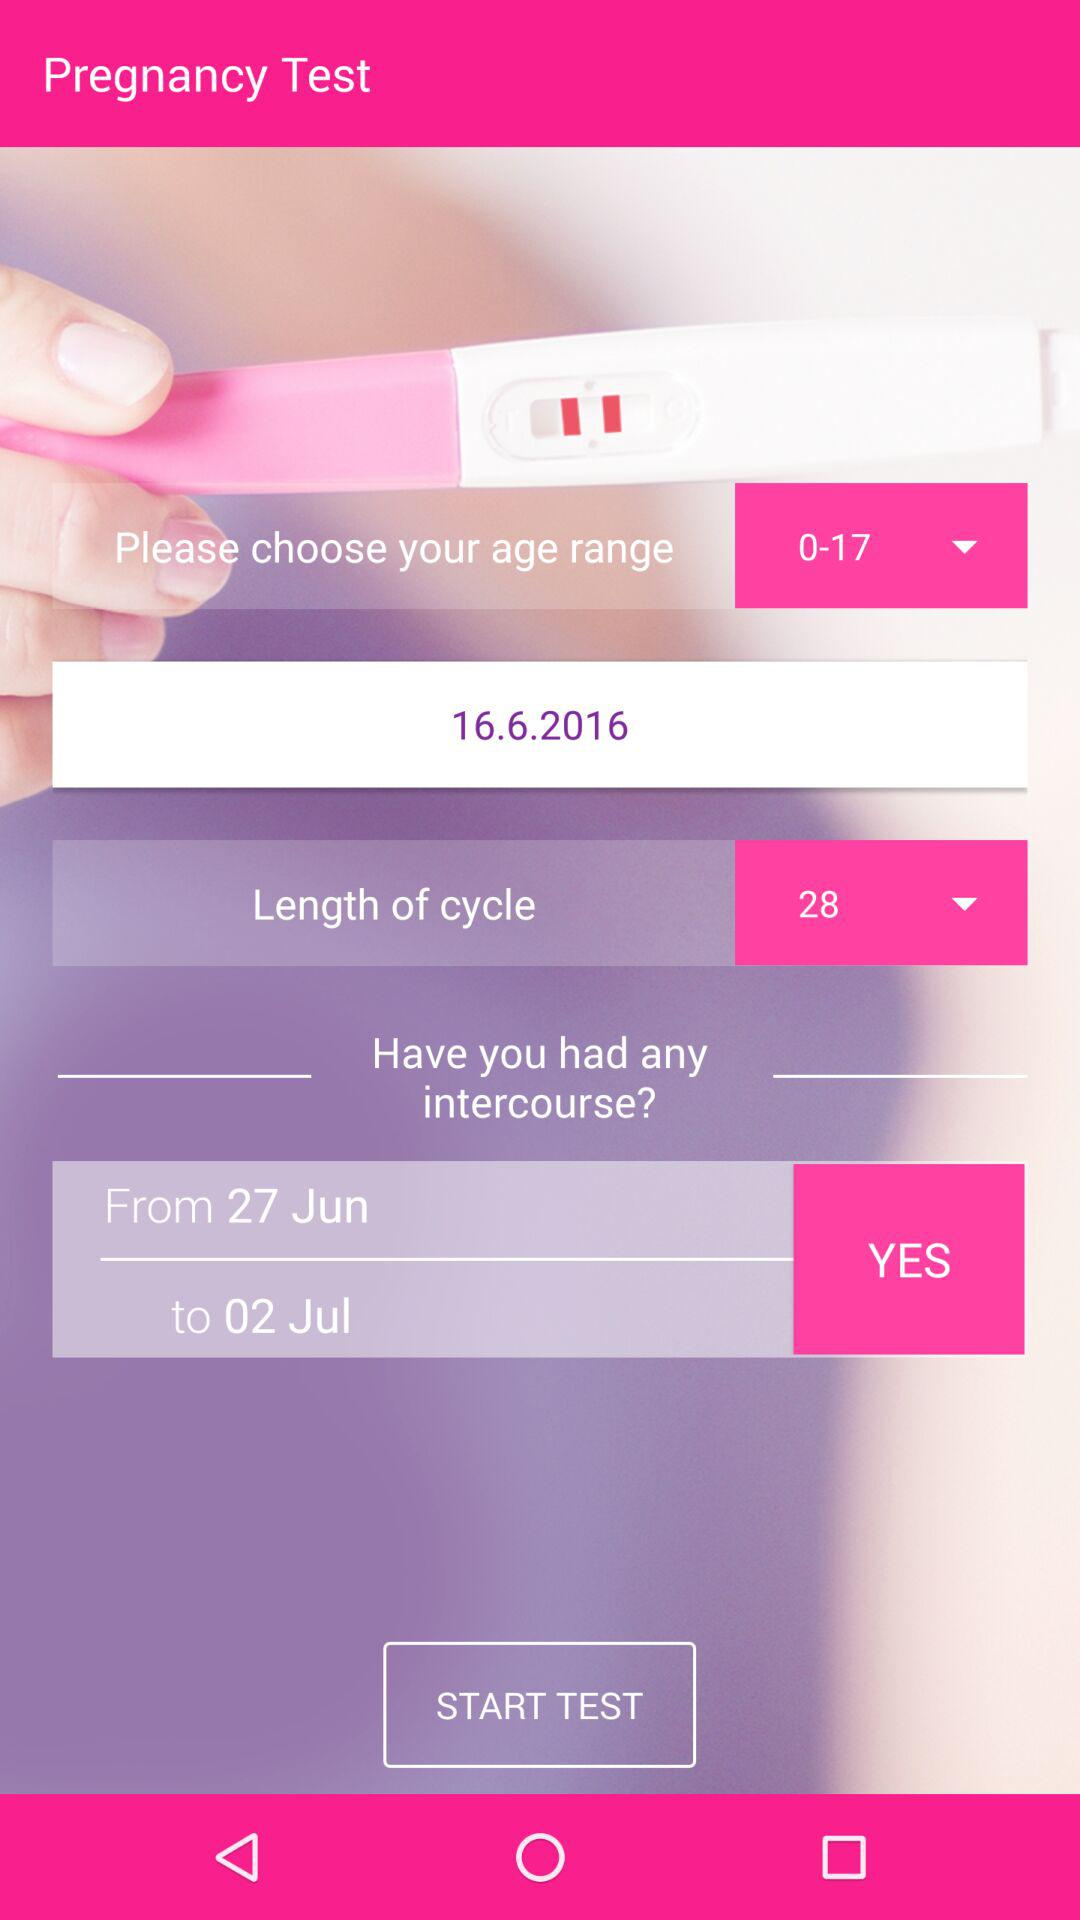What is the selected date? The selected date is June 16, 2016. 